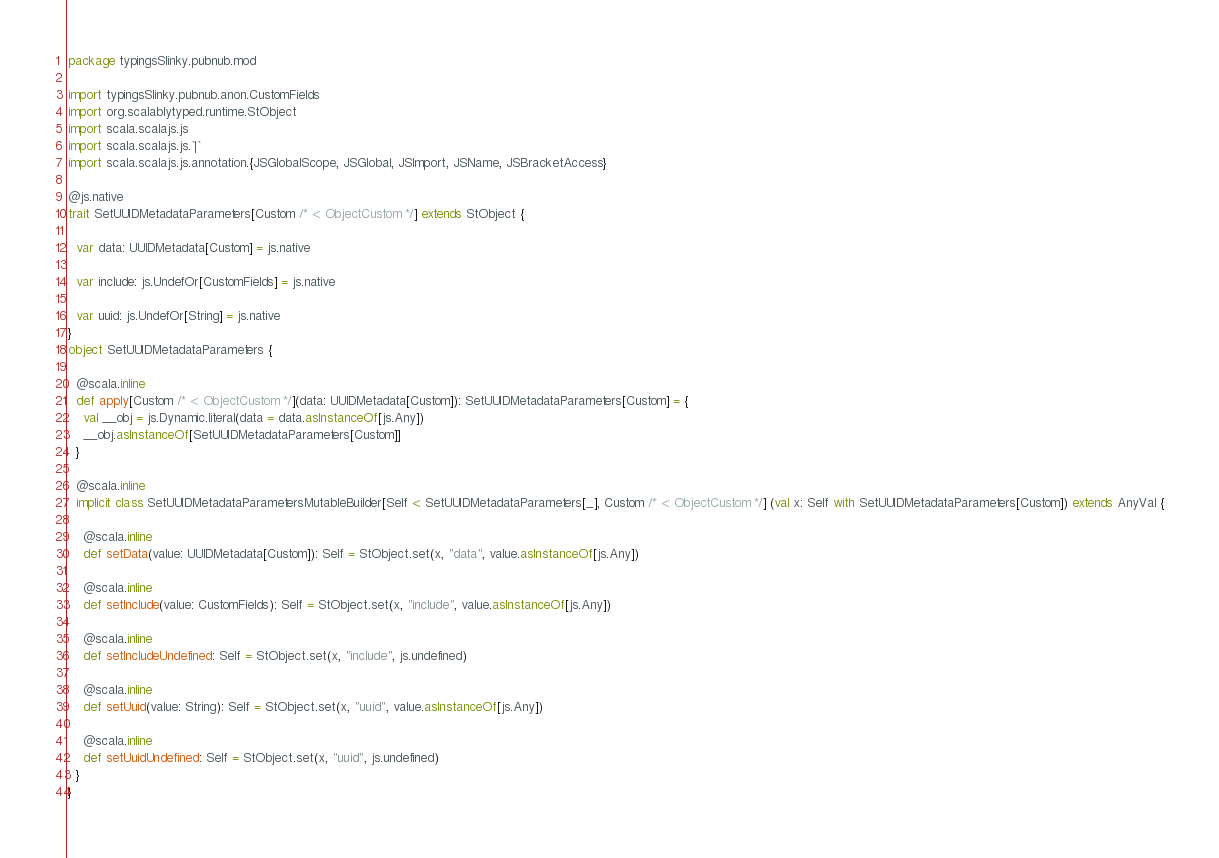Convert code to text. <code><loc_0><loc_0><loc_500><loc_500><_Scala_>package typingsSlinky.pubnub.mod

import typingsSlinky.pubnub.anon.CustomFields
import org.scalablytyped.runtime.StObject
import scala.scalajs.js
import scala.scalajs.js.`|`
import scala.scalajs.js.annotation.{JSGlobalScope, JSGlobal, JSImport, JSName, JSBracketAccess}

@js.native
trait SetUUIDMetadataParameters[Custom /* <: ObjectCustom */] extends StObject {
  
  var data: UUIDMetadata[Custom] = js.native
  
  var include: js.UndefOr[CustomFields] = js.native
  
  var uuid: js.UndefOr[String] = js.native
}
object SetUUIDMetadataParameters {
  
  @scala.inline
  def apply[Custom /* <: ObjectCustom */](data: UUIDMetadata[Custom]): SetUUIDMetadataParameters[Custom] = {
    val __obj = js.Dynamic.literal(data = data.asInstanceOf[js.Any])
    __obj.asInstanceOf[SetUUIDMetadataParameters[Custom]]
  }
  
  @scala.inline
  implicit class SetUUIDMetadataParametersMutableBuilder[Self <: SetUUIDMetadataParameters[_], Custom /* <: ObjectCustom */] (val x: Self with SetUUIDMetadataParameters[Custom]) extends AnyVal {
    
    @scala.inline
    def setData(value: UUIDMetadata[Custom]): Self = StObject.set(x, "data", value.asInstanceOf[js.Any])
    
    @scala.inline
    def setInclude(value: CustomFields): Self = StObject.set(x, "include", value.asInstanceOf[js.Any])
    
    @scala.inline
    def setIncludeUndefined: Self = StObject.set(x, "include", js.undefined)
    
    @scala.inline
    def setUuid(value: String): Self = StObject.set(x, "uuid", value.asInstanceOf[js.Any])
    
    @scala.inline
    def setUuidUndefined: Self = StObject.set(x, "uuid", js.undefined)
  }
}
</code> 